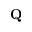<formula> <loc_0><loc_0><loc_500><loc_500>Q</formula> 